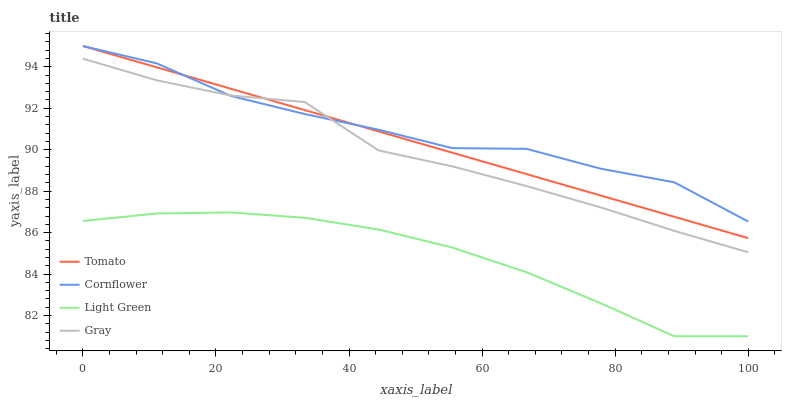Does Light Green have the minimum area under the curve?
Answer yes or no. Yes. Does Cornflower have the maximum area under the curve?
Answer yes or no. Yes. Does Cornflower have the minimum area under the curve?
Answer yes or no. No. Does Light Green have the maximum area under the curve?
Answer yes or no. No. Is Tomato the smoothest?
Answer yes or no. Yes. Is Cornflower the roughest?
Answer yes or no. Yes. Is Light Green the smoothest?
Answer yes or no. No. Is Light Green the roughest?
Answer yes or no. No. Does Light Green have the lowest value?
Answer yes or no. Yes. Does Cornflower have the lowest value?
Answer yes or no. No. Does Cornflower have the highest value?
Answer yes or no. Yes. Does Light Green have the highest value?
Answer yes or no. No. Is Light Green less than Gray?
Answer yes or no. Yes. Is Tomato greater than Light Green?
Answer yes or no. Yes. Does Gray intersect Cornflower?
Answer yes or no. Yes. Is Gray less than Cornflower?
Answer yes or no. No. Is Gray greater than Cornflower?
Answer yes or no. No. Does Light Green intersect Gray?
Answer yes or no. No. 